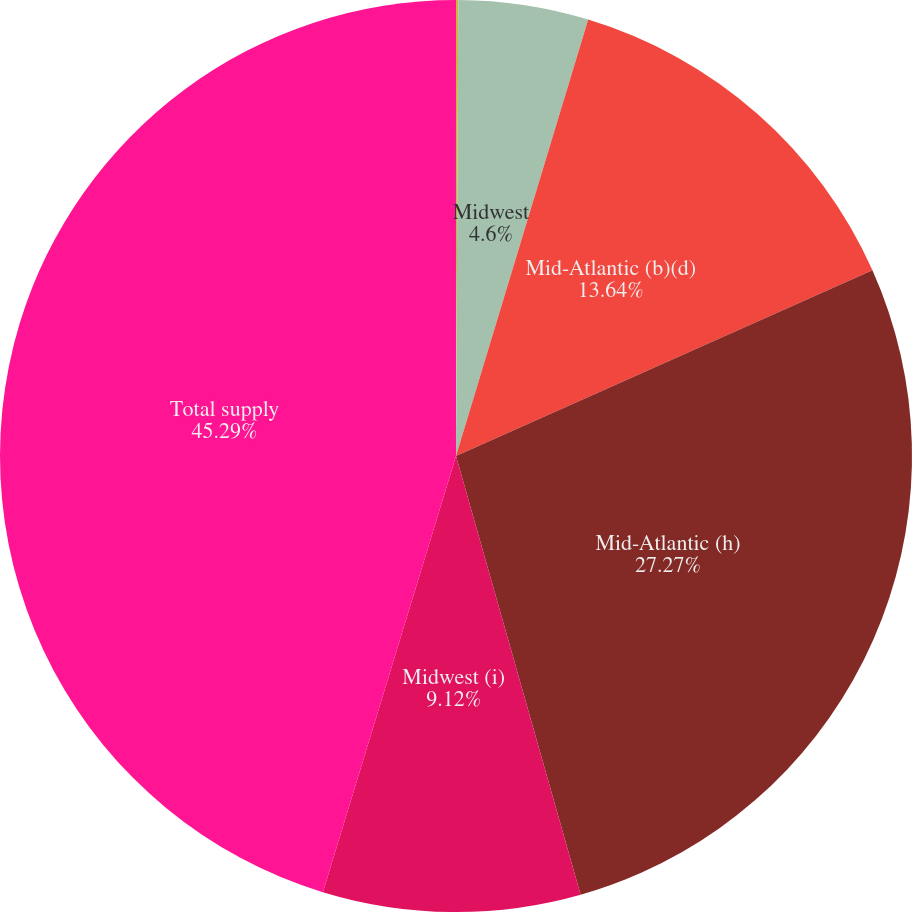Convert chart to OTSL. <chart><loc_0><loc_0><loc_500><loc_500><pie_chart><fcel>Mid-Atlantic<fcel>Midwest<fcel>Mid-Atlantic (b)(d)<fcel>Mid-Atlantic (h)<fcel>Midwest (i)<fcel>Total supply<nl><fcel>0.08%<fcel>4.6%<fcel>13.64%<fcel>27.27%<fcel>9.12%<fcel>45.28%<nl></chart> 